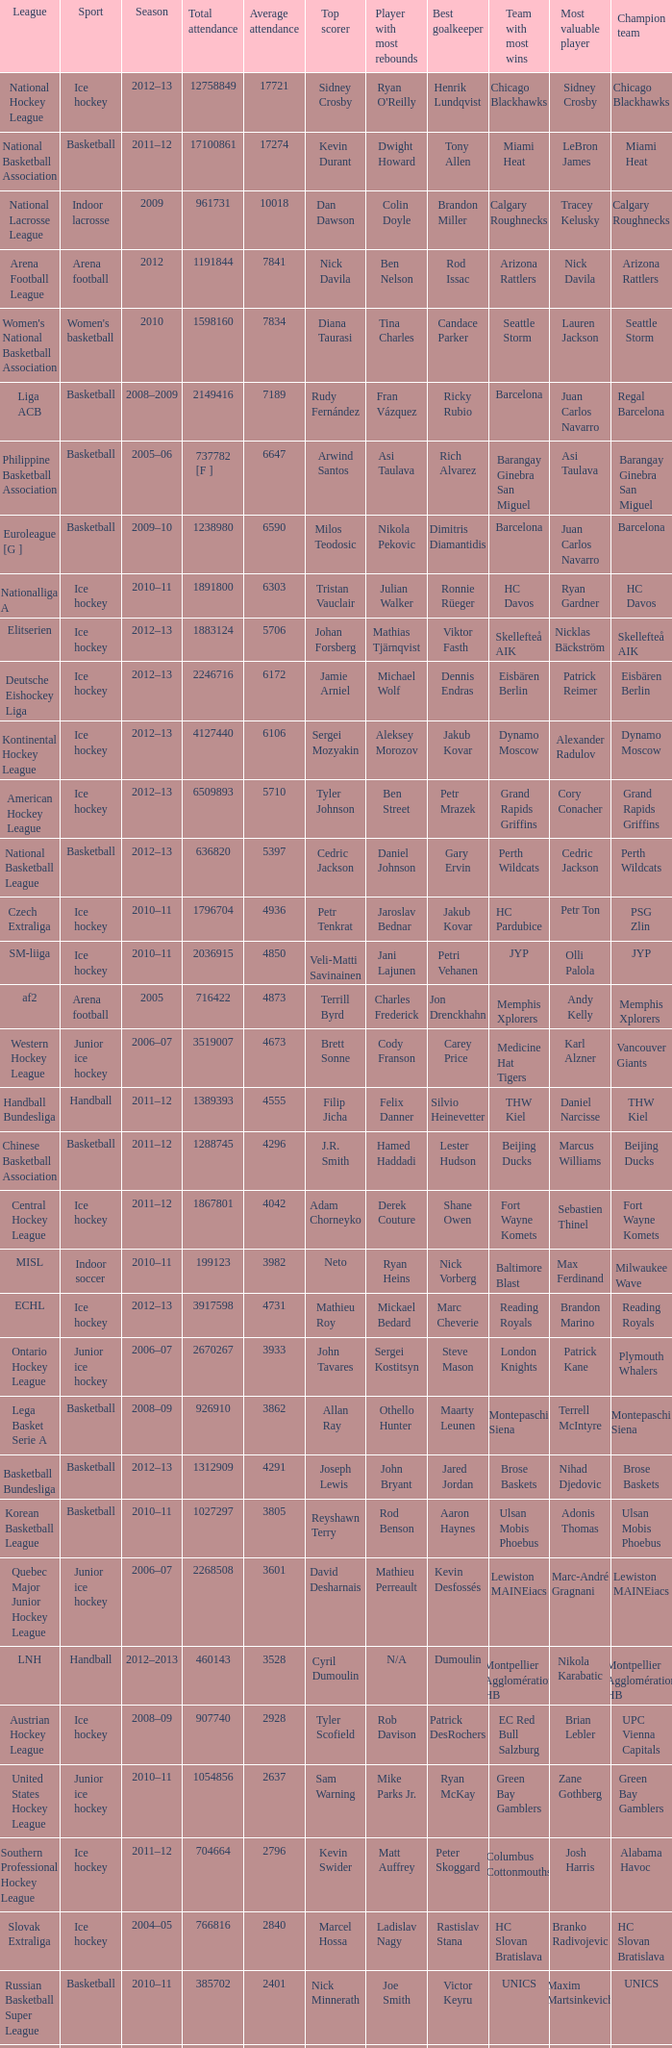What's the total attendance in rink hockey when the average attendance was smaller than 4850? 115000.0. 